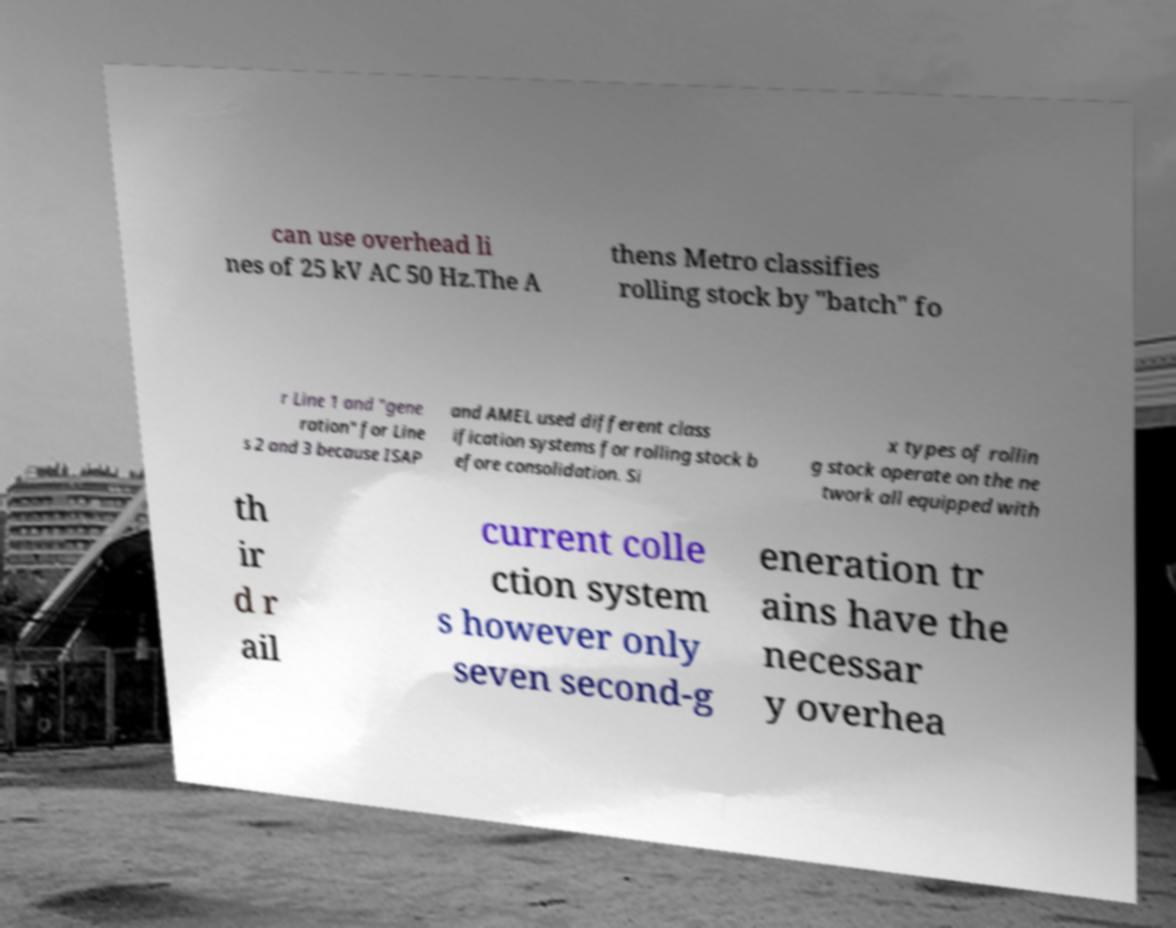Please read and relay the text visible in this image. What does it say? can use overhead li nes of 25 kV AC 50 Hz.The A thens Metro classifies rolling stock by "batch" fo r Line 1 and "gene ration" for Line s 2 and 3 because ISAP and AMEL used different class ification systems for rolling stock b efore consolidation. Si x types of rollin g stock operate on the ne twork all equipped with th ir d r ail current colle ction system s however only seven second-g eneration tr ains have the necessar y overhea 